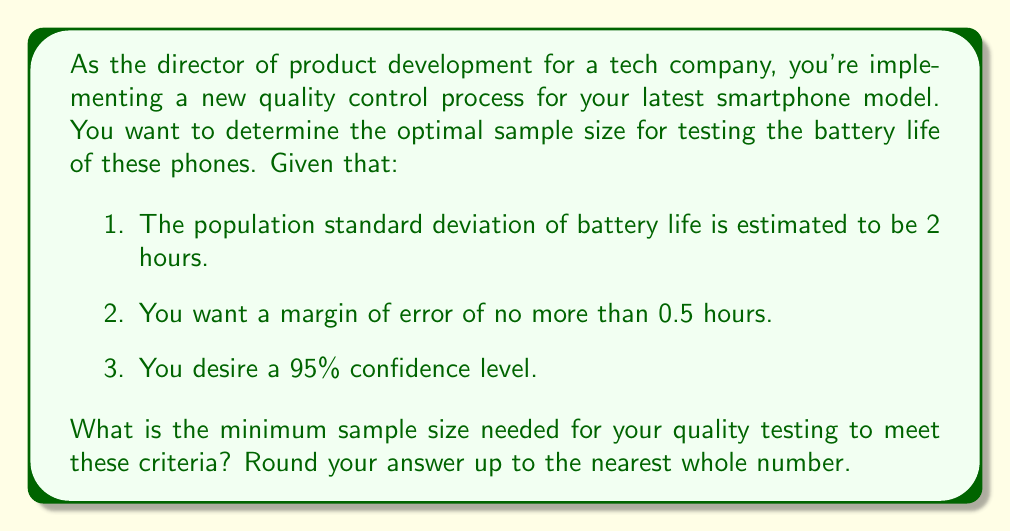Could you help me with this problem? To determine the optimal sample size for this scenario, we'll use the formula for sample size calculation:

$$ n = \left(\frac{z_{\alpha/2} \cdot \sigma}{E}\right)^2 $$

Where:
$n$ = sample size
$z_{\alpha/2}$ = z-score for the desired confidence level
$\sigma$ = population standard deviation
$E$ = margin of error

Step 1: Identify the known values
- Confidence level = 95%, so $z_{\alpha/2} = 1.96$
- $\sigma = 2$ hours
- $E = 0.5$ hours

Step 2: Plug the values into the formula
$$ n = \left(\frac{1.96 \cdot 2}{0.5}\right)^2 $$

Step 3: Simplify and calculate
$$ n = \left(\frac{3.92}{0.5}\right)^2 = 7.84^2 = 61.4656 $$

Step 4: Round up to the nearest whole number
$n = 62$

In the context of Agile methodologies and Total Quality Management (TQM), this sample size ensures that you have statistically significant data to make informed decisions about product quality while maintaining efficiency in your testing process.
Answer: 62 smartphones 